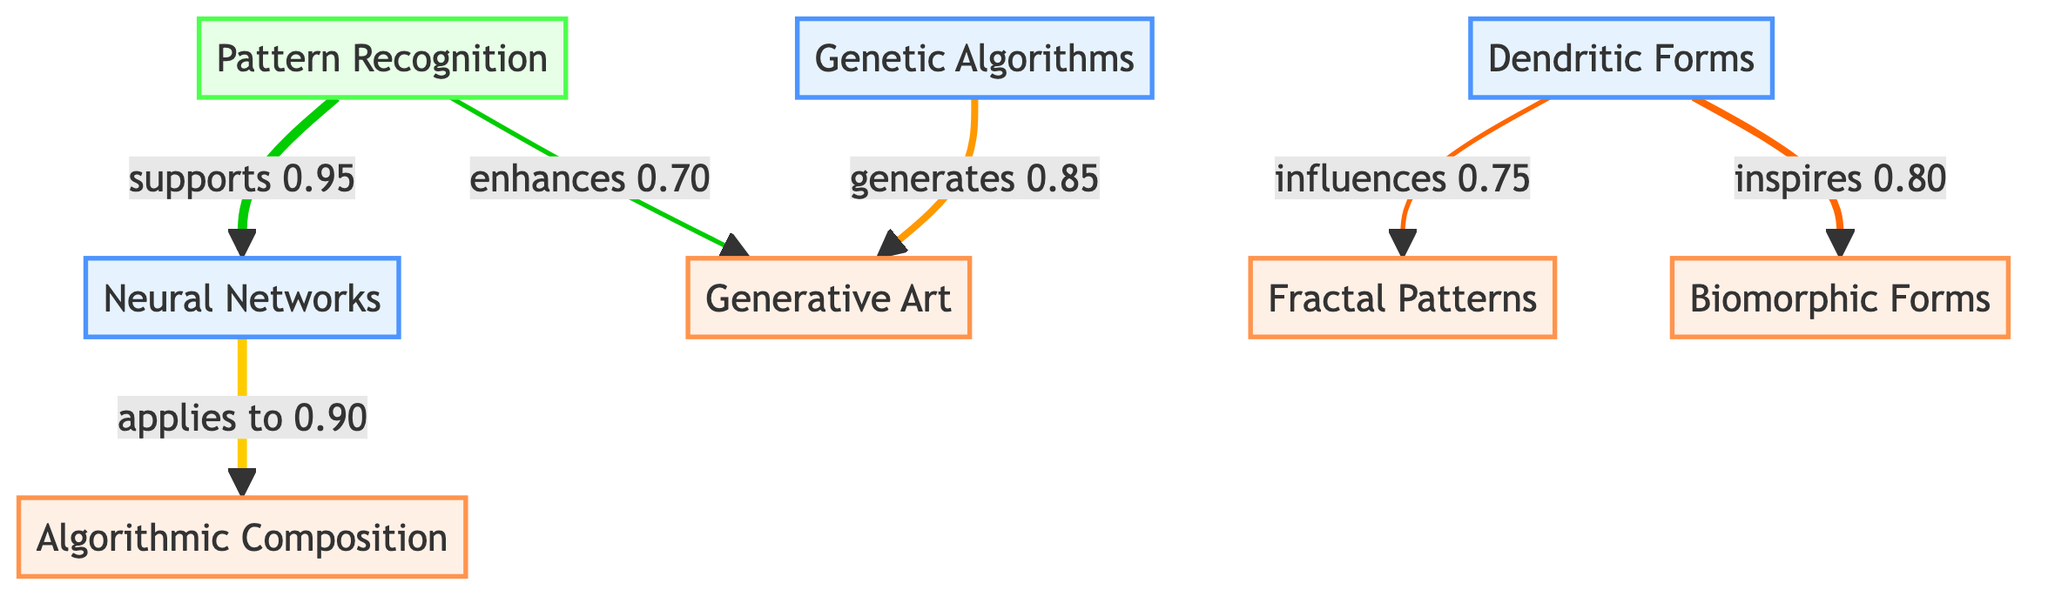What is the influence value from Dendritic Forms to Fractal Patterns? According to the diagram, the influence from Dendritic Forms to Fractal Patterns is indicated as 0.75, which is shown as a label on the connecting arrow between the two nodes.
Answer: 0.75 How many design elements are represented in the diagram? The diagram features four distinct design elements, which include Fractal Patterns, Generative Art, Algorithmic Composition, and Biomorphic Forms. Each of these elements is depicted as a separate node.
Answer: 4 Which biological factor has the highest influence on a design element? The biological factor Neural Networks has the highest influence on Algorithmic Composition, indicated by the influence value of 0.90, the highest among the directed influences shown in the diagram.
Answer: 0.90 What is the relationship between Genetic Algorithms and Generative Art? The diagram indicates that Genetic Algorithms generates Generative Art with an influence value of 0.85, meaning Genetic Algorithms contributes significantly to the creation of Generative Art.
Answer: generates 0.85 Which methodology supports Neural Networks? The diagram shows that Pattern Recognition is the methodology that supports Neural Networks, as indicated by the directed arrow connecting them and the label on the connection.
Answer: Pattern Recognition Which design element is inspired by Dendritic Forms? The design element inspired by Dendritic Forms is Biomorphic Forms, as indicated by the direct connection from Dendritic Forms to Biomorphic Forms with an influence of 0.80.
Answer: Biomorphic Forms What is the influence value of Pattern Recognition enhancing Generative Art? The influence value of Pattern Recognition enhancing Generative Art is 0.70, presented on the corresponding arrow between the nodes in the diagram.
Answer: 0.70 Which two biological factors are connected to the design elements Fractal Patterns and Algorithmic Composition? The biological factors connected to Fractal Patterns and Algorithmic Composition are Dendritic Forms and Neural Networks, respectively; these connections show their influence over these design elements.
Answer: Dendritic Forms, Neural Networks 